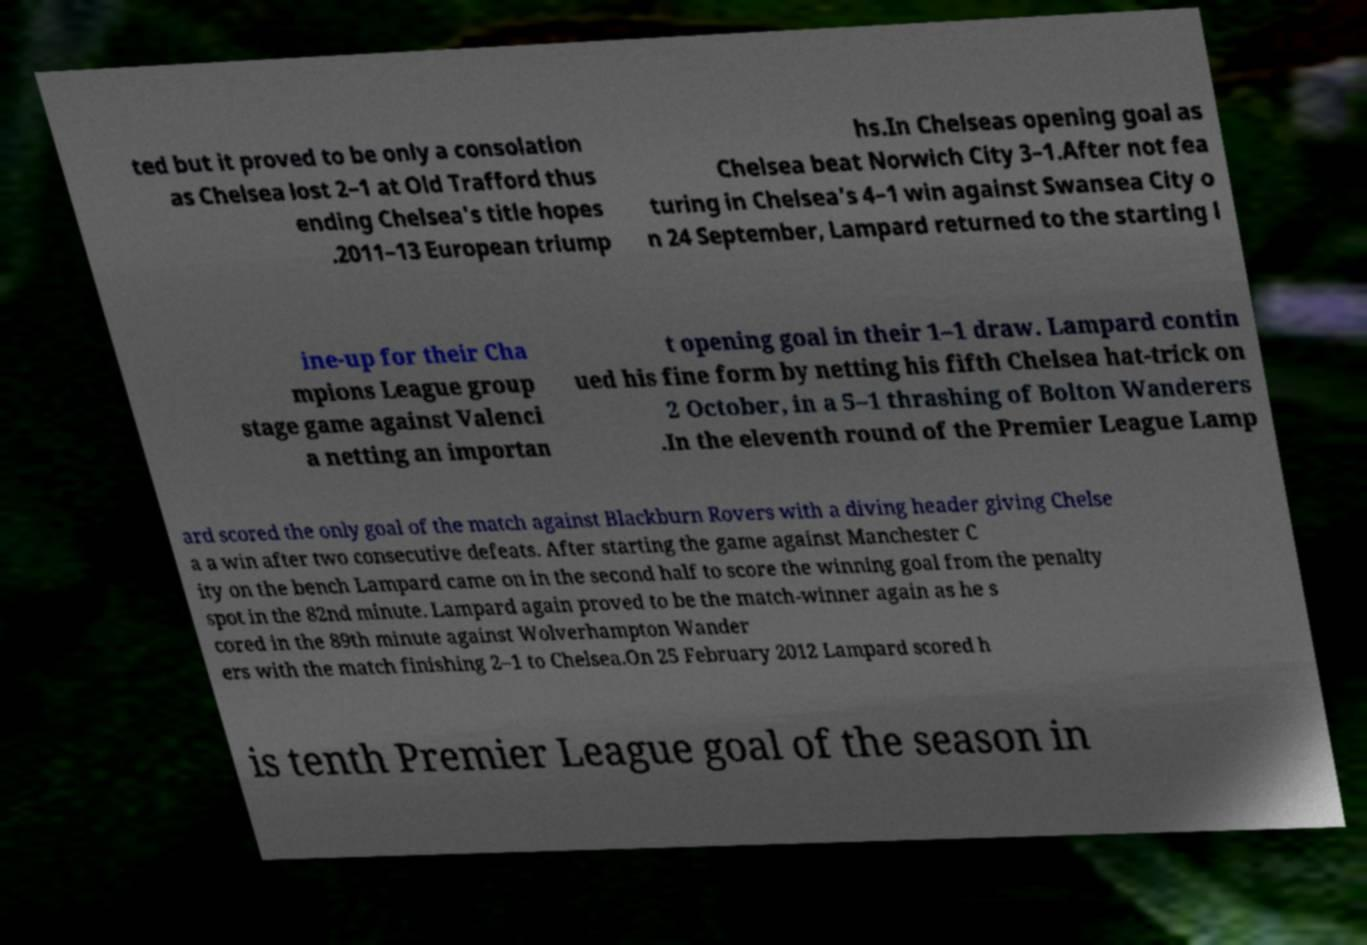Can you read and provide the text displayed in the image?This photo seems to have some interesting text. Can you extract and type it out for me? ted but it proved to be only a consolation as Chelsea lost 2–1 at Old Trafford thus ending Chelsea's title hopes .2011–13 European triump hs.In Chelseas opening goal as Chelsea beat Norwich City 3–1.After not fea turing in Chelsea's 4–1 win against Swansea City o n 24 September, Lampard returned to the starting l ine-up for their Cha mpions League group stage game against Valenci a netting an importan t opening goal in their 1–1 draw. Lampard contin ued his fine form by netting his fifth Chelsea hat-trick on 2 October, in a 5–1 thrashing of Bolton Wanderers .In the eleventh round of the Premier League Lamp ard scored the only goal of the match against Blackburn Rovers with a diving header giving Chelse a a win after two consecutive defeats. After starting the game against Manchester C ity on the bench Lampard came on in the second half to score the winning goal from the penalty spot in the 82nd minute. Lampard again proved to be the match-winner again as he s cored in the 89th minute against Wolverhampton Wander ers with the match finishing 2–1 to Chelsea.On 25 February 2012 Lampard scored h is tenth Premier League goal of the season in 